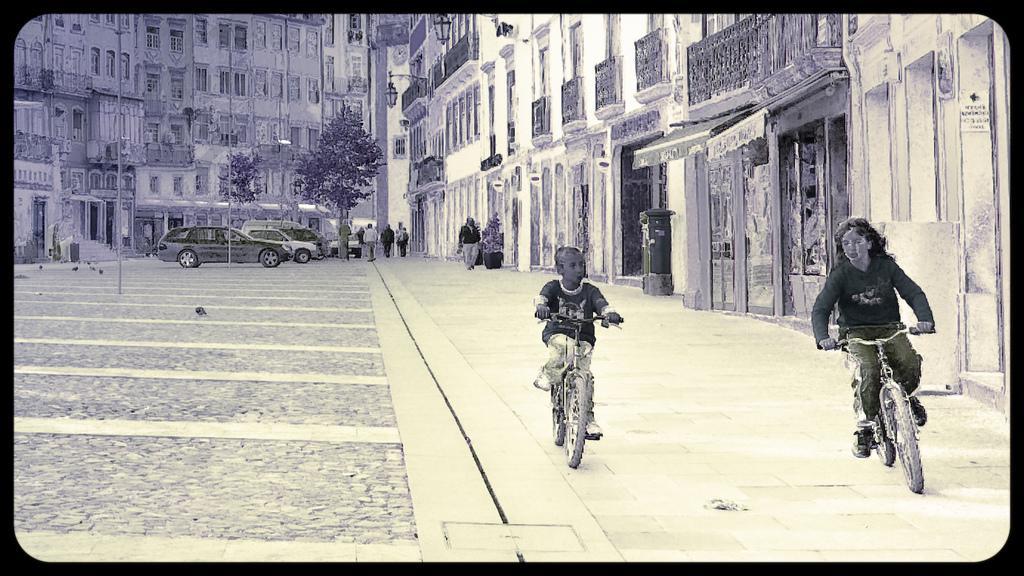Could you give a brief overview of what you see in this image? This edited image is clicked on the road. To the left there is a road. There are cars parked on the road. To the right there is a walkway. There is a girl and a boy riding bicycles on the walkway. In the background there are buildings. There are lamps on the walls of the building. In front of the buildings there are trees. There are poles on the road. There are a few people walking on the walkway. 